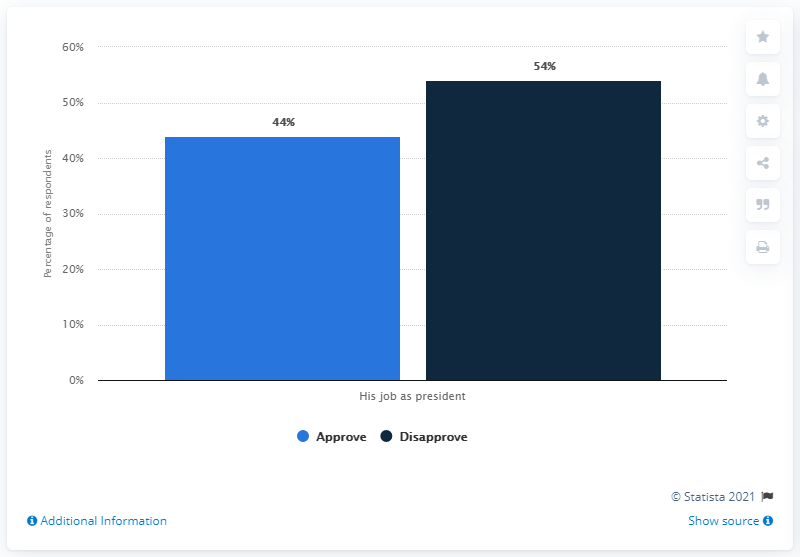Mention a couple of crucial points in this snapshot. According to the given data, approximately 2% of the respondents had no opinion or did not vote. According to a recent poll, 54% of people disapprove of Trump's performance as president. 